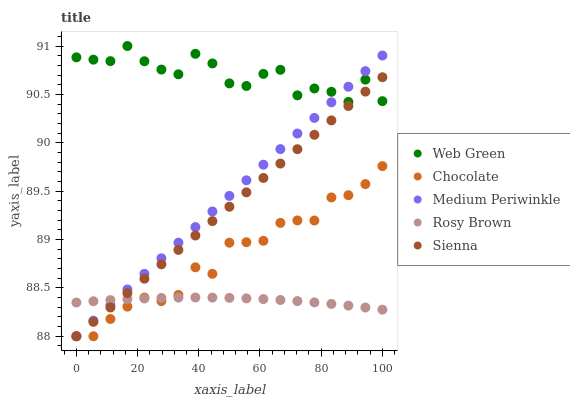Does Rosy Brown have the minimum area under the curve?
Answer yes or no. Yes. Does Web Green have the maximum area under the curve?
Answer yes or no. Yes. Does Medium Periwinkle have the minimum area under the curve?
Answer yes or no. No. Does Medium Periwinkle have the maximum area under the curve?
Answer yes or no. No. Is Sienna the smoothest?
Answer yes or no. Yes. Is Web Green the roughest?
Answer yes or no. Yes. Is Rosy Brown the smoothest?
Answer yes or no. No. Is Rosy Brown the roughest?
Answer yes or no. No. Does Sienna have the lowest value?
Answer yes or no. Yes. Does Rosy Brown have the lowest value?
Answer yes or no. No. Does Web Green have the highest value?
Answer yes or no. Yes. Does Medium Periwinkle have the highest value?
Answer yes or no. No. Is Chocolate less than Web Green?
Answer yes or no. Yes. Is Web Green greater than Rosy Brown?
Answer yes or no. Yes. Does Chocolate intersect Medium Periwinkle?
Answer yes or no. Yes. Is Chocolate less than Medium Periwinkle?
Answer yes or no. No. Is Chocolate greater than Medium Periwinkle?
Answer yes or no. No. Does Chocolate intersect Web Green?
Answer yes or no. No. 